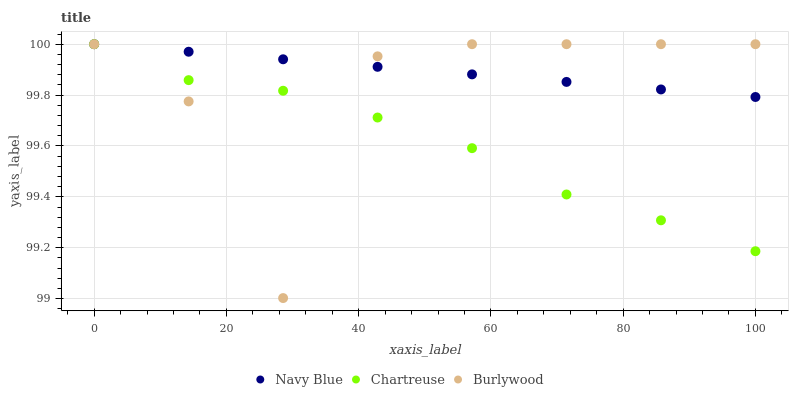Does Chartreuse have the minimum area under the curve?
Answer yes or no. Yes. Does Navy Blue have the maximum area under the curve?
Answer yes or no. Yes. Does Navy Blue have the minimum area under the curve?
Answer yes or no. No. Does Chartreuse have the maximum area under the curve?
Answer yes or no. No. Is Navy Blue the smoothest?
Answer yes or no. Yes. Is Burlywood the roughest?
Answer yes or no. Yes. Is Chartreuse the smoothest?
Answer yes or no. No. Is Chartreuse the roughest?
Answer yes or no. No. Does Burlywood have the lowest value?
Answer yes or no. Yes. Does Chartreuse have the lowest value?
Answer yes or no. No. Does Chartreuse have the highest value?
Answer yes or no. Yes. Does Burlywood intersect Chartreuse?
Answer yes or no. Yes. Is Burlywood less than Chartreuse?
Answer yes or no. No. Is Burlywood greater than Chartreuse?
Answer yes or no. No. 